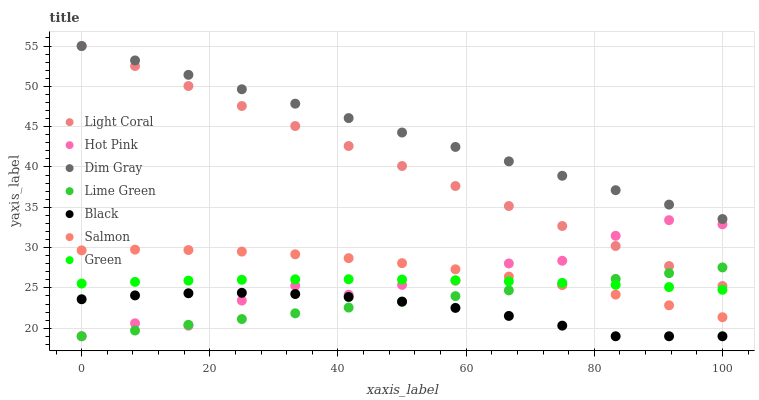Does Black have the minimum area under the curve?
Answer yes or no. Yes. Does Dim Gray have the maximum area under the curve?
Answer yes or no. Yes. Does Hot Pink have the minimum area under the curve?
Answer yes or no. No. Does Hot Pink have the maximum area under the curve?
Answer yes or no. No. Is Lime Green the smoothest?
Answer yes or no. Yes. Is Hot Pink the roughest?
Answer yes or no. Yes. Is Salmon the smoothest?
Answer yes or no. No. Is Salmon the roughest?
Answer yes or no. No. Does Hot Pink have the lowest value?
Answer yes or no. Yes. Does Salmon have the lowest value?
Answer yes or no. No. Does Light Coral have the highest value?
Answer yes or no. Yes. Does Hot Pink have the highest value?
Answer yes or no. No. Is Lime Green less than Dim Gray?
Answer yes or no. Yes. Is Light Coral greater than Green?
Answer yes or no. Yes. Does Hot Pink intersect Salmon?
Answer yes or no. Yes. Is Hot Pink less than Salmon?
Answer yes or no. No. Is Hot Pink greater than Salmon?
Answer yes or no. No. Does Lime Green intersect Dim Gray?
Answer yes or no. No. 